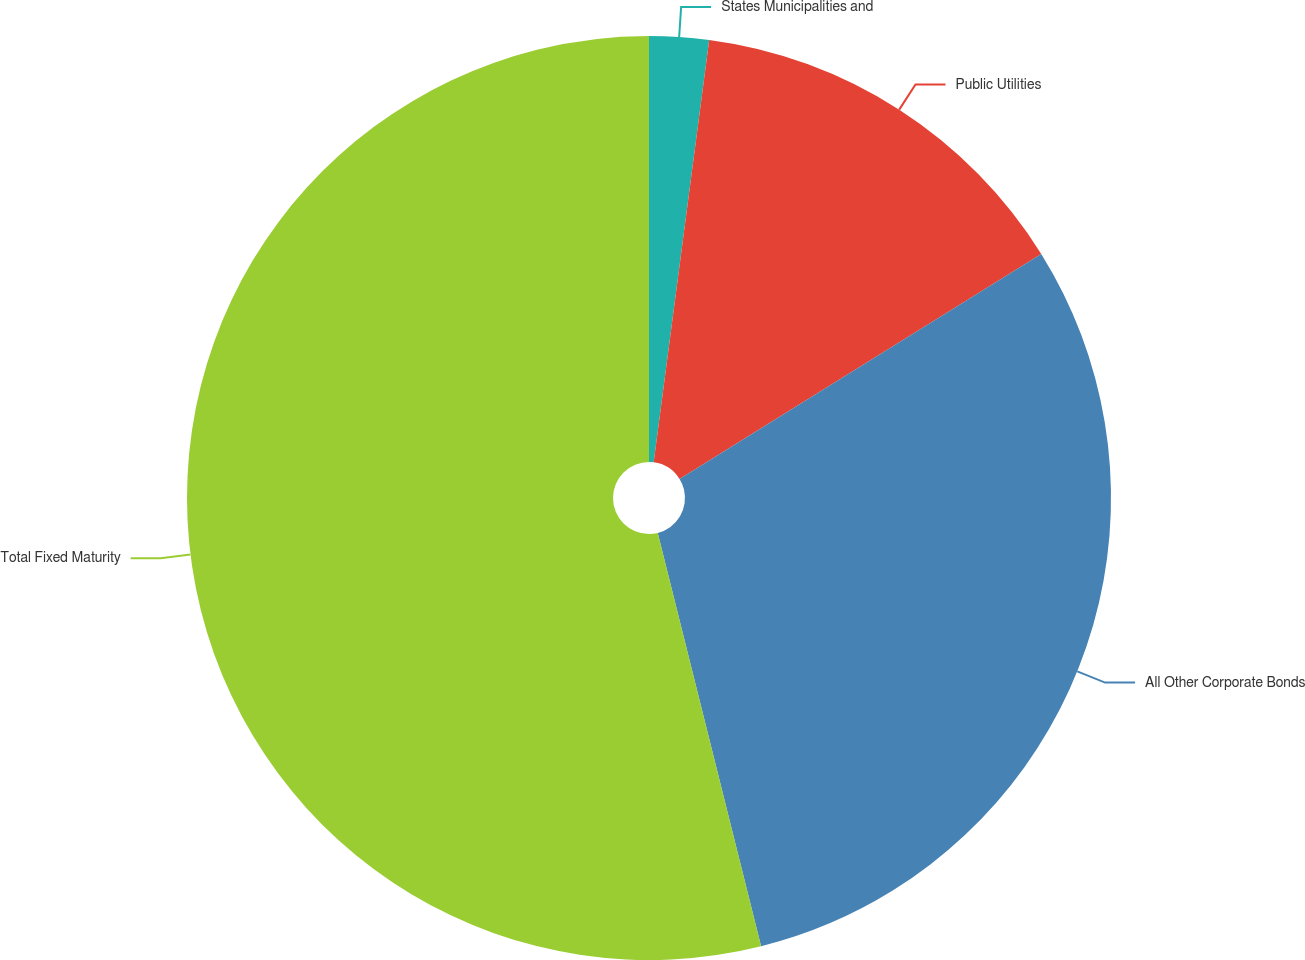Convert chart to OTSL. <chart><loc_0><loc_0><loc_500><loc_500><pie_chart><fcel>States Municipalities and<fcel>Public Utilities<fcel>All Other Corporate Bonds<fcel>Total Fixed Maturity<nl><fcel>2.08%<fcel>14.06%<fcel>29.96%<fcel>53.9%<nl></chart> 